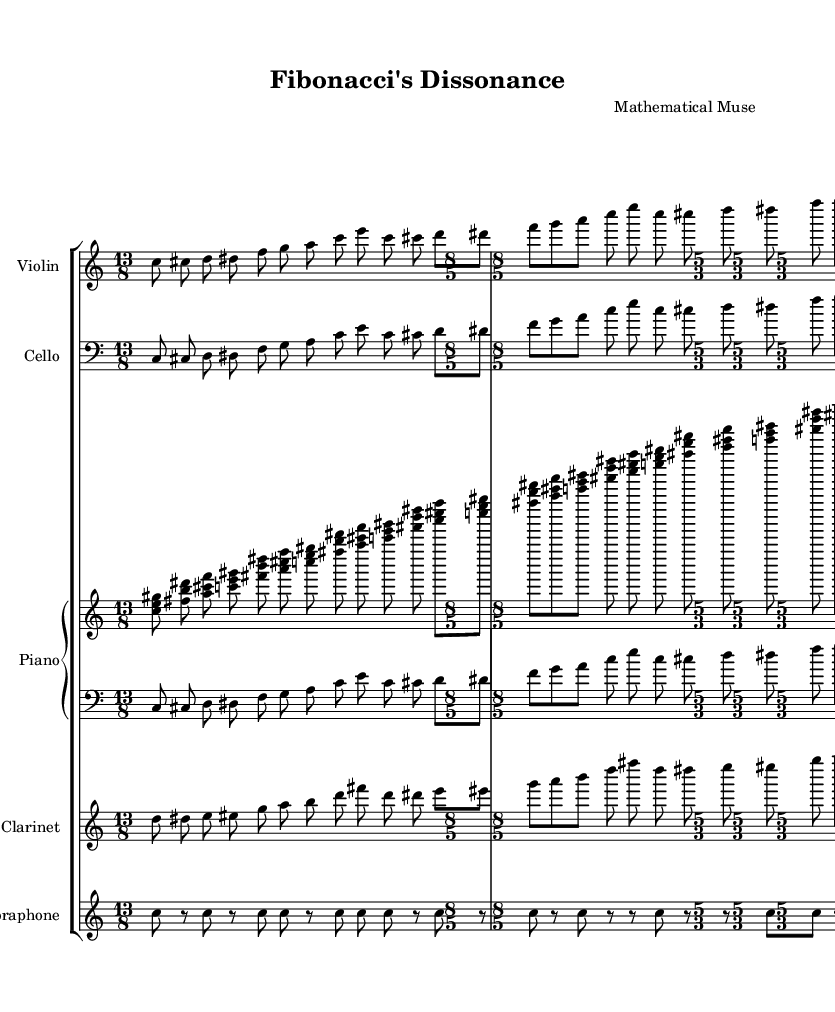What is the title of this music? The title is stated at the beginning of the score in the header section. It reads "Fibonacci's Dissonance".
Answer: Fibonacci's Dissonance What is the time signature of the first section? The first section of the score indicates the time signature by displaying "13/8" at the start of the violin and cello staves.
Answer: 13/8 How many instruments are included in this composition? By analyzing the score, there are five distinct staves representing five different instruments: Violin, Cello, Piano, Clarinet, and Vibraphone.
Answer: Five What is the clef used for the cello part? The cello part is marked with a "bass" clef at the beginning of its staff, indicated clearly in the header of the staff.
Answer: Bass In which measure does the Piano section first play a chord? By examining the piano staff, the first chord occurs in the very first measure when three notes are played together.
Answer: First measure What concept do the rhythms in the Vibraphone suggest? The rhythm in the Vibraphone part, with its repetitive structure and rests, could imply an exploration of randomness or unpredictable patterns, typical of experimental music linked to mathematical ideas.
Answer: Randomness How does the time signature change throughout the piece? The piece starts in 13/8, then shifts to 8/5 in the second section, and finally to 5/3 in the last section, indicating a variation in rhythmic complexity and style.
Answer: It changes from 13/8 to 8/5 to 5/3 